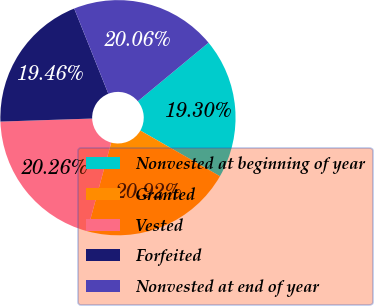<chart> <loc_0><loc_0><loc_500><loc_500><pie_chart><fcel>Nonvested at beginning of year<fcel>Granted<fcel>Vested<fcel>Forfeited<fcel>Nonvested at end of year<nl><fcel>19.3%<fcel>20.92%<fcel>20.26%<fcel>19.46%<fcel>20.06%<nl></chart> 